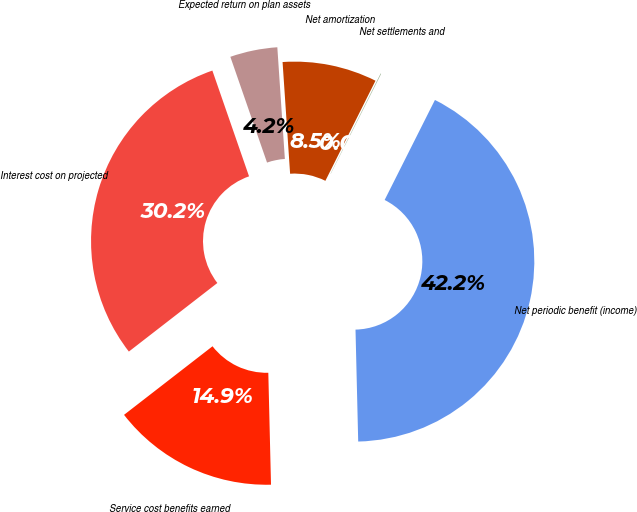<chart> <loc_0><loc_0><loc_500><loc_500><pie_chart><fcel>Service cost benefits earned<fcel>Interest cost on projected<fcel>Expected return on plan assets<fcel>Net amortization<fcel>Net settlements and<fcel>Net periodic benefit (income)<nl><fcel>14.89%<fcel>30.18%<fcel>4.24%<fcel>8.46%<fcel>0.03%<fcel>42.2%<nl></chart> 